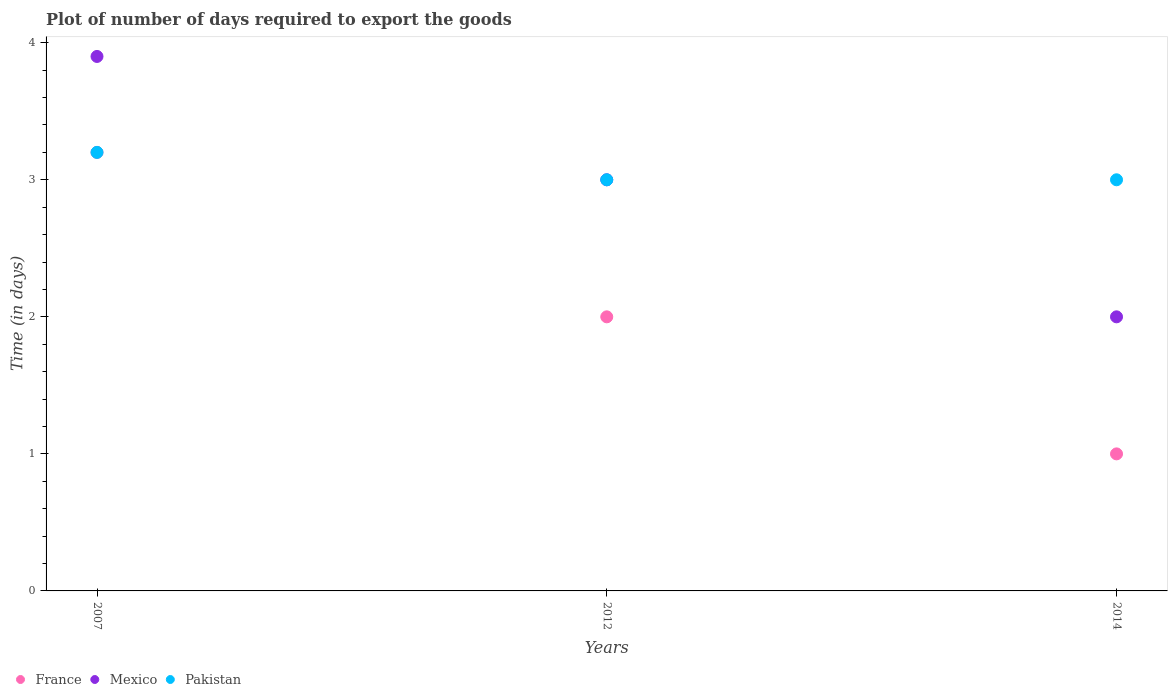How many different coloured dotlines are there?
Keep it short and to the point. 3. Across all years, what is the maximum time required to export goods in Mexico?
Your response must be concise. 3.9. Across all years, what is the minimum time required to export goods in Mexico?
Offer a very short reply. 2. What is the total time required to export goods in Pakistan in the graph?
Provide a short and direct response. 9.2. What is the difference between the time required to export goods in France in 2007 and that in 2012?
Provide a short and direct response. 1.2. What is the difference between the time required to export goods in France in 2014 and the time required to export goods in Mexico in 2012?
Make the answer very short. -2. What is the average time required to export goods in France per year?
Your response must be concise. 2.07. In the year 2007, what is the difference between the time required to export goods in Pakistan and time required to export goods in France?
Your answer should be very brief. 0. In how many years, is the time required to export goods in France greater than 1.4 days?
Provide a short and direct response. 2. What is the ratio of the time required to export goods in Mexico in 2007 to that in 2014?
Your response must be concise. 1.95. Is the difference between the time required to export goods in Pakistan in 2012 and 2014 greater than the difference between the time required to export goods in France in 2012 and 2014?
Ensure brevity in your answer.  No. What is the difference between the highest and the second highest time required to export goods in France?
Provide a short and direct response. 1.2. What is the difference between the highest and the lowest time required to export goods in Pakistan?
Give a very brief answer. 0.2. In how many years, is the time required to export goods in Mexico greater than the average time required to export goods in Mexico taken over all years?
Give a very brief answer. 2. Does the time required to export goods in Mexico monotonically increase over the years?
Offer a very short reply. No. Is the time required to export goods in France strictly less than the time required to export goods in Mexico over the years?
Your answer should be compact. Yes. How many dotlines are there?
Give a very brief answer. 3. How many years are there in the graph?
Make the answer very short. 3. What is the difference between two consecutive major ticks on the Y-axis?
Provide a succinct answer. 1. How many legend labels are there?
Give a very brief answer. 3. What is the title of the graph?
Make the answer very short. Plot of number of days required to export the goods. What is the label or title of the X-axis?
Offer a terse response. Years. What is the label or title of the Y-axis?
Your answer should be very brief. Time (in days). What is the Time (in days) of France in 2007?
Offer a terse response. 3.2. What is the Time (in days) in Mexico in 2007?
Ensure brevity in your answer.  3.9. What is the Time (in days) in Pakistan in 2007?
Provide a short and direct response. 3.2. What is the Time (in days) of France in 2012?
Your response must be concise. 2. What is the Time (in days) of Mexico in 2012?
Make the answer very short. 3. What is the Time (in days) in Pakistan in 2012?
Your answer should be very brief. 3. What is the Time (in days) in Mexico in 2014?
Your answer should be very brief. 2. Across all years, what is the maximum Time (in days) of Pakistan?
Make the answer very short. 3.2. Across all years, what is the minimum Time (in days) in France?
Make the answer very short. 1. Across all years, what is the minimum Time (in days) of Mexico?
Keep it short and to the point. 2. Across all years, what is the minimum Time (in days) of Pakistan?
Your response must be concise. 3. What is the total Time (in days) in France in the graph?
Provide a short and direct response. 6.2. What is the total Time (in days) in Mexico in the graph?
Provide a succinct answer. 8.9. What is the difference between the Time (in days) of France in 2007 and that in 2012?
Offer a very short reply. 1.2. What is the difference between the Time (in days) of Pakistan in 2007 and that in 2012?
Provide a succinct answer. 0.2. What is the difference between the Time (in days) of Mexico in 2012 and that in 2014?
Make the answer very short. 1. What is the difference between the Time (in days) in Mexico in 2007 and the Time (in days) in Pakistan in 2012?
Ensure brevity in your answer.  0.9. What is the difference between the Time (in days) of France in 2007 and the Time (in days) of Pakistan in 2014?
Make the answer very short. 0.2. What is the difference between the Time (in days) in France in 2012 and the Time (in days) in Pakistan in 2014?
Ensure brevity in your answer.  -1. What is the difference between the Time (in days) of Mexico in 2012 and the Time (in days) of Pakistan in 2014?
Make the answer very short. 0. What is the average Time (in days) in France per year?
Keep it short and to the point. 2.07. What is the average Time (in days) of Mexico per year?
Offer a very short reply. 2.97. What is the average Time (in days) in Pakistan per year?
Keep it short and to the point. 3.07. In the year 2007, what is the difference between the Time (in days) in Mexico and Time (in days) in Pakistan?
Give a very brief answer. 0.7. In the year 2012, what is the difference between the Time (in days) in France and Time (in days) in Pakistan?
Make the answer very short. -1. In the year 2014, what is the difference between the Time (in days) in France and Time (in days) in Mexico?
Your answer should be compact. -1. In the year 2014, what is the difference between the Time (in days) of France and Time (in days) of Pakistan?
Ensure brevity in your answer.  -2. In the year 2014, what is the difference between the Time (in days) in Mexico and Time (in days) in Pakistan?
Your answer should be very brief. -1. What is the ratio of the Time (in days) of France in 2007 to that in 2012?
Provide a succinct answer. 1.6. What is the ratio of the Time (in days) in Mexico in 2007 to that in 2012?
Offer a terse response. 1.3. What is the ratio of the Time (in days) of Pakistan in 2007 to that in 2012?
Give a very brief answer. 1.07. What is the ratio of the Time (in days) in Mexico in 2007 to that in 2014?
Provide a short and direct response. 1.95. What is the ratio of the Time (in days) in Pakistan in 2007 to that in 2014?
Provide a succinct answer. 1.07. What is the ratio of the Time (in days) in France in 2012 to that in 2014?
Your response must be concise. 2. What is the ratio of the Time (in days) in Mexico in 2012 to that in 2014?
Ensure brevity in your answer.  1.5. What is the difference between the highest and the second highest Time (in days) in France?
Your answer should be very brief. 1.2. What is the difference between the highest and the second highest Time (in days) of Pakistan?
Provide a short and direct response. 0.2. What is the difference between the highest and the lowest Time (in days) in Pakistan?
Your answer should be very brief. 0.2. 